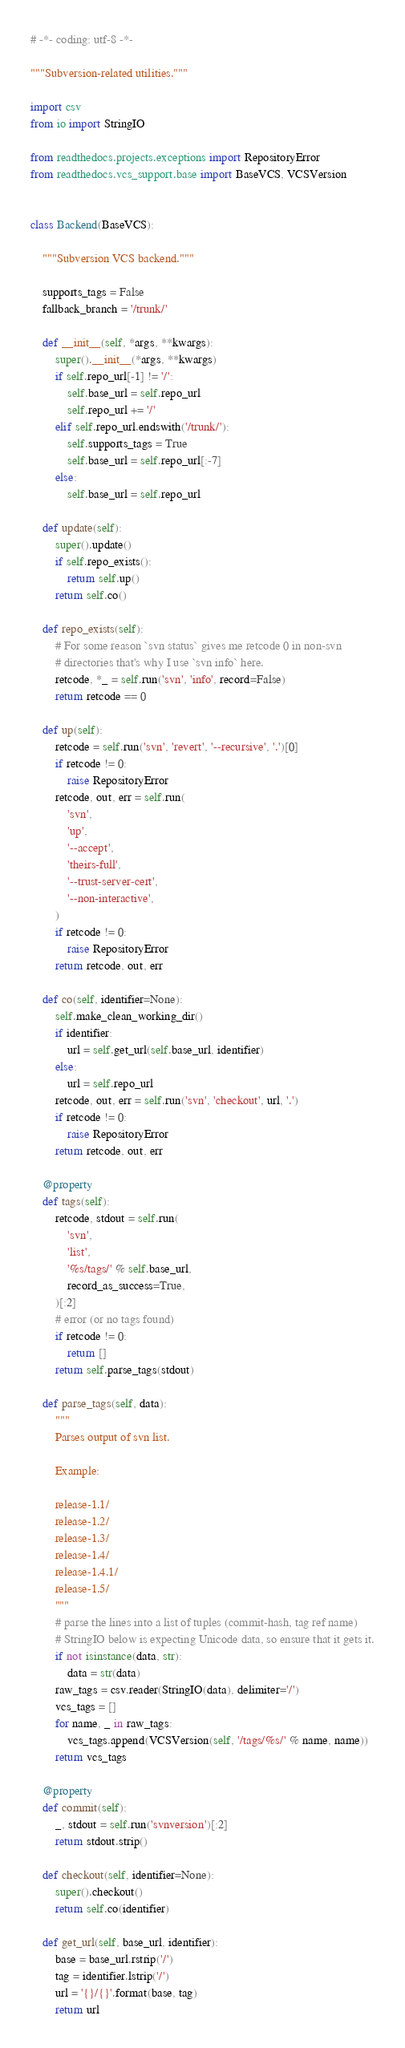<code> <loc_0><loc_0><loc_500><loc_500><_Python_># -*- coding: utf-8 -*-

"""Subversion-related utilities."""

import csv
from io import StringIO

from readthedocs.projects.exceptions import RepositoryError
from readthedocs.vcs_support.base import BaseVCS, VCSVersion


class Backend(BaseVCS):

    """Subversion VCS backend."""

    supports_tags = False
    fallback_branch = '/trunk/'

    def __init__(self, *args, **kwargs):
        super().__init__(*args, **kwargs)
        if self.repo_url[-1] != '/':
            self.base_url = self.repo_url
            self.repo_url += '/'
        elif self.repo_url.endswith('/trunk/'):
            self.supports_tags = True
            self.base_url = self.repo_url[:-7]
        else:
            self.base_url = self.repo_url

    def update(self):
        super().update()
        if self.repo_exists():
            return self.up()
        return self.co()

    def repo_exists(self):
        # For some reason `svn status` gives me retcode 0 in non-svn
        # directories that's why I use `svn info` here.
        retcode, *_ = self.run('svn', 'info', record=False)
        return retcode == 0

    def up(self):
        retcode = self.run('svn', 'revert', '--recursive', '.')[0]
        if retcode != 0:
            raise RepositoryError
        retcode, out, err = self.run(
            'svn',
            'up',
            '--accept',
            'theirs-full',
            '--trust-server-cert',
            '--non-interactive',
        )
        if retcode != 0:
            raise RepositoryError
        return retcode, out, err

    def co(self, identifier=None):
        self.make_clean_working_dir()
        if identifier:
            url = self.get_url(self.base_url, identifier)
        else:
            url = self.repo_url
        retcode, out, err = self.run('svn', 'checkout', url, '.')
        if retcode != 0:
            raise RepositoryError
        return retcode, out, err

    @property
    def tags(self):
        retcode, stdout = self.run(
            'svn',
            'list',
            '%s/tags/' % self.base_url,
            record_as_success=True,
        )[:2]
        # error (or no tags found)
        if retcode != 0:
            return []
        return self.parse_tags(stdout)

    def parse_tags(self, data):
        """
        Parses output of svn list.

        Example:

        release-1.1/
        release-1.2/
        release-1.3/
        release-1.4/
        release-1.4.1/
        release-1.5/
        """
        # parse the lines into a list of tuples (commit-hash, tag ref name)
        # StringIO below is expecting Unicode data, so ensure that it gets it.
        if not isinstance(data, str):
            data = str(data)
        raw_tags = csv.reader(StringIO(data), delimiter='/')
        vcs_tags = []
        for name, _ in raw_tags:
            vcs_tags.append(VCSVersion(self, '/tags/%s/' % name, name))
        return vcs_tags

    @property
    def commit(self):
        _, stdout = self.run('svnversion')[:2]
        return stdout.strip()

    def checkout(self, identifier=None):
        super().checkout()
        return self.co(identifier)

    def get_url(self, base_url, identifier):
        base = base_url.rstrip('/')
        tag = identifier.lstrip('/')
        url = '{}/{}'.format(base, tag)
        return url
</code> 